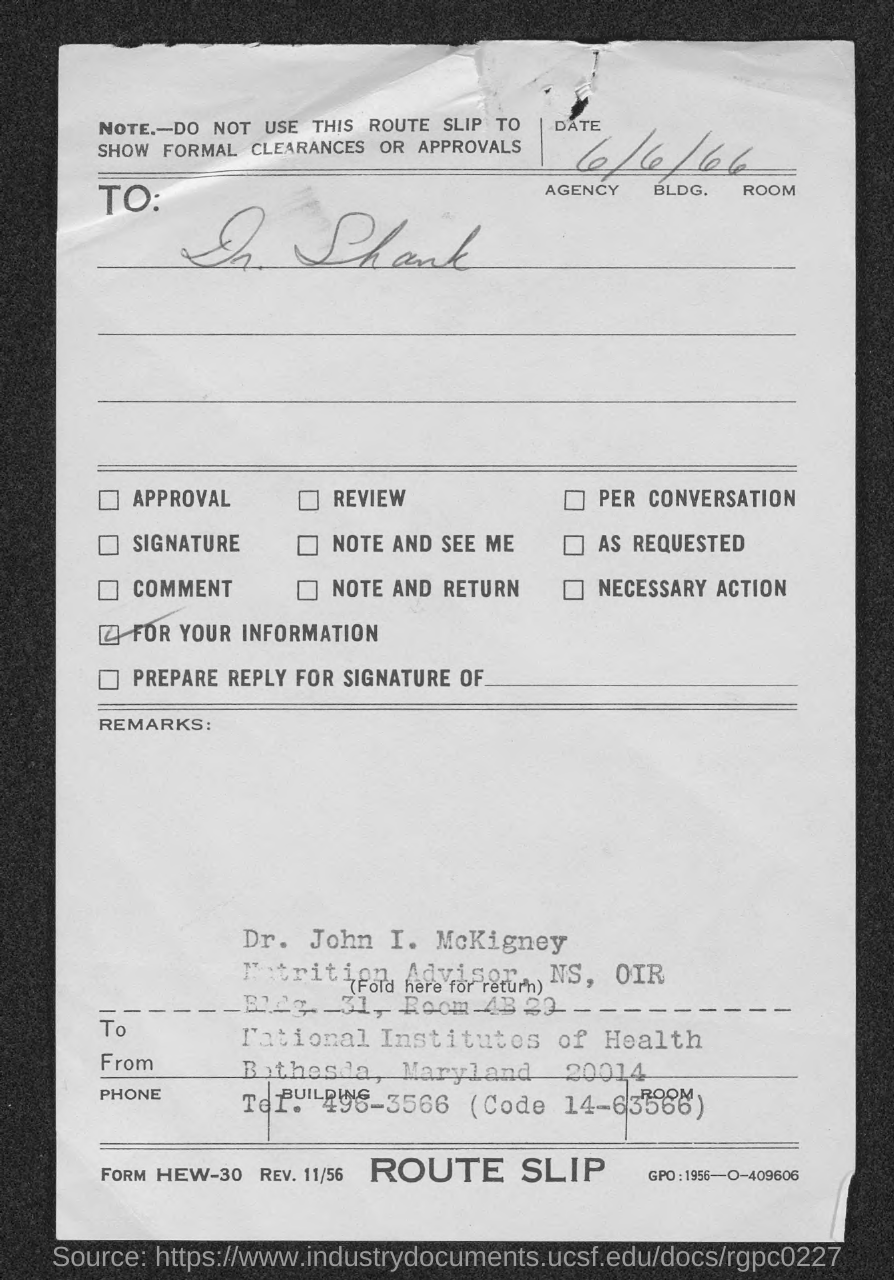Identify some key points in this picture. This letter is addressed to Dr. Shank. The date is 6/6/66. 